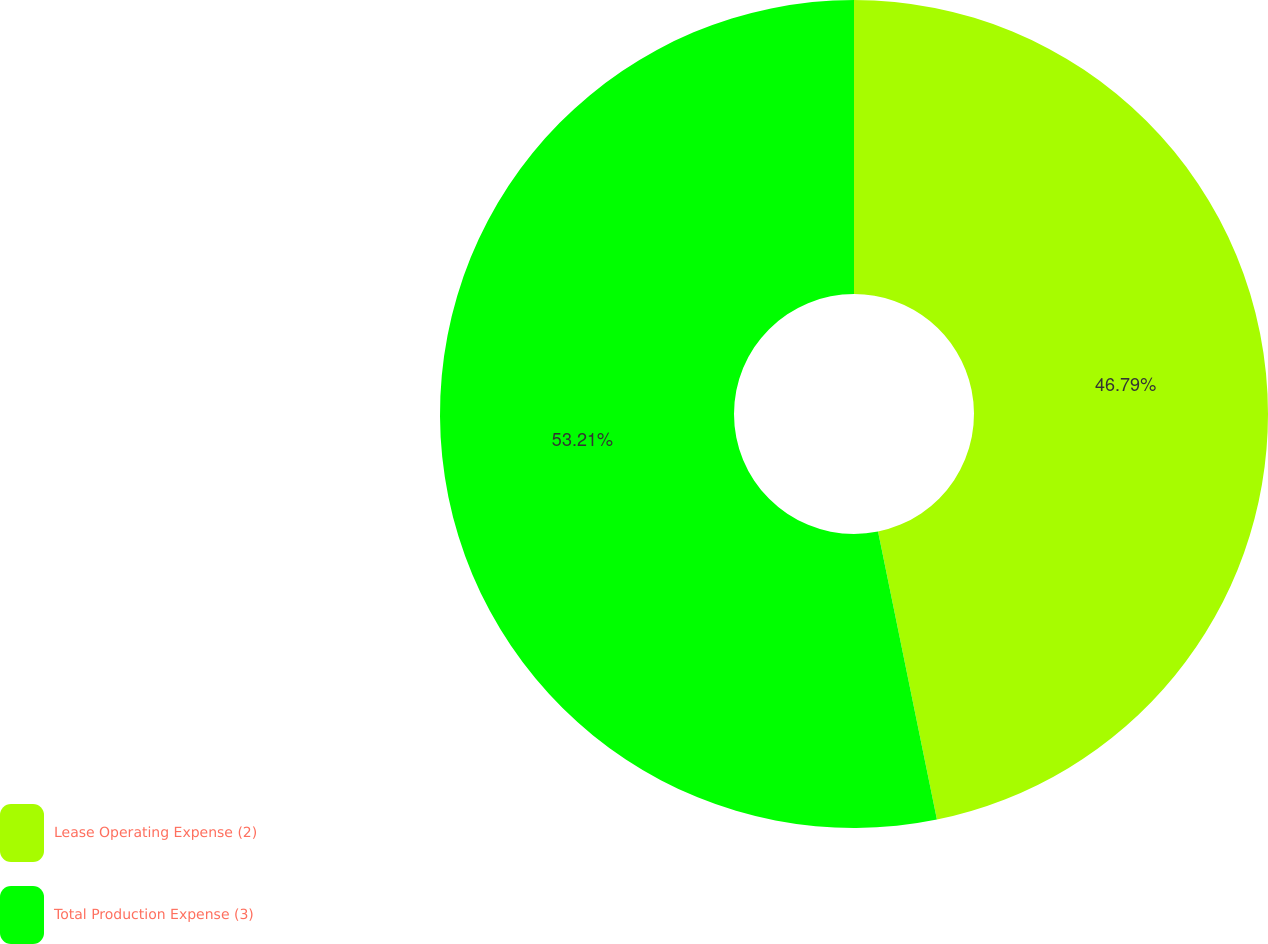Convert chart. <chart><loc_0><loc_0><loc_500><loc_500><pie_chart><fcel>Lease Operating Expense (2)<fcel>Total Production Expense (3)<nl><fcel>46.79%<fcel>53.21%<nl></chart> 